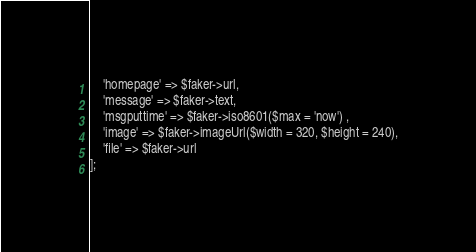Convert code to text. <code><loc_0><loc_0><loc_500><loc_500><_PHP_>	'homepage' => $faker->url,
	'message' => $faker->text,
	'msgputtime' => $faker->iso8601($max = 'now') ,
	'image' => $faker->imageUrl($width = 320, $height = 240),
	'file' => $faker->url 
];</code> 